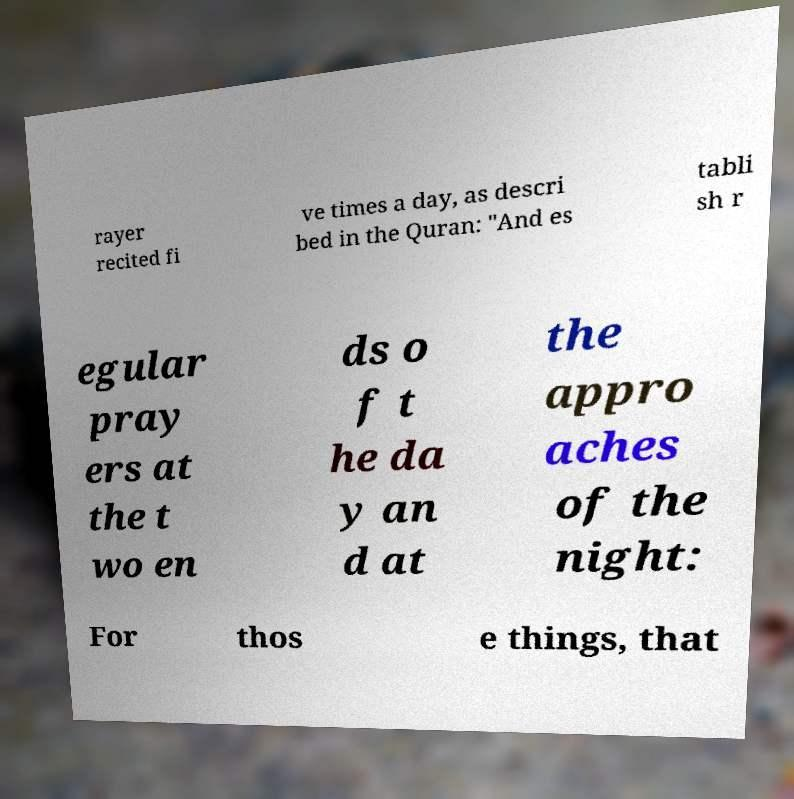For documentation purposes, I need the text within this image transcribed. Could you provide that? rayer recited fi ve times a day, as descri bed in the Quran: "And es tabli sh r egular pray ers at the t wo en ds o f t he da y an d at the appro aches of the night: For thos e things, that 